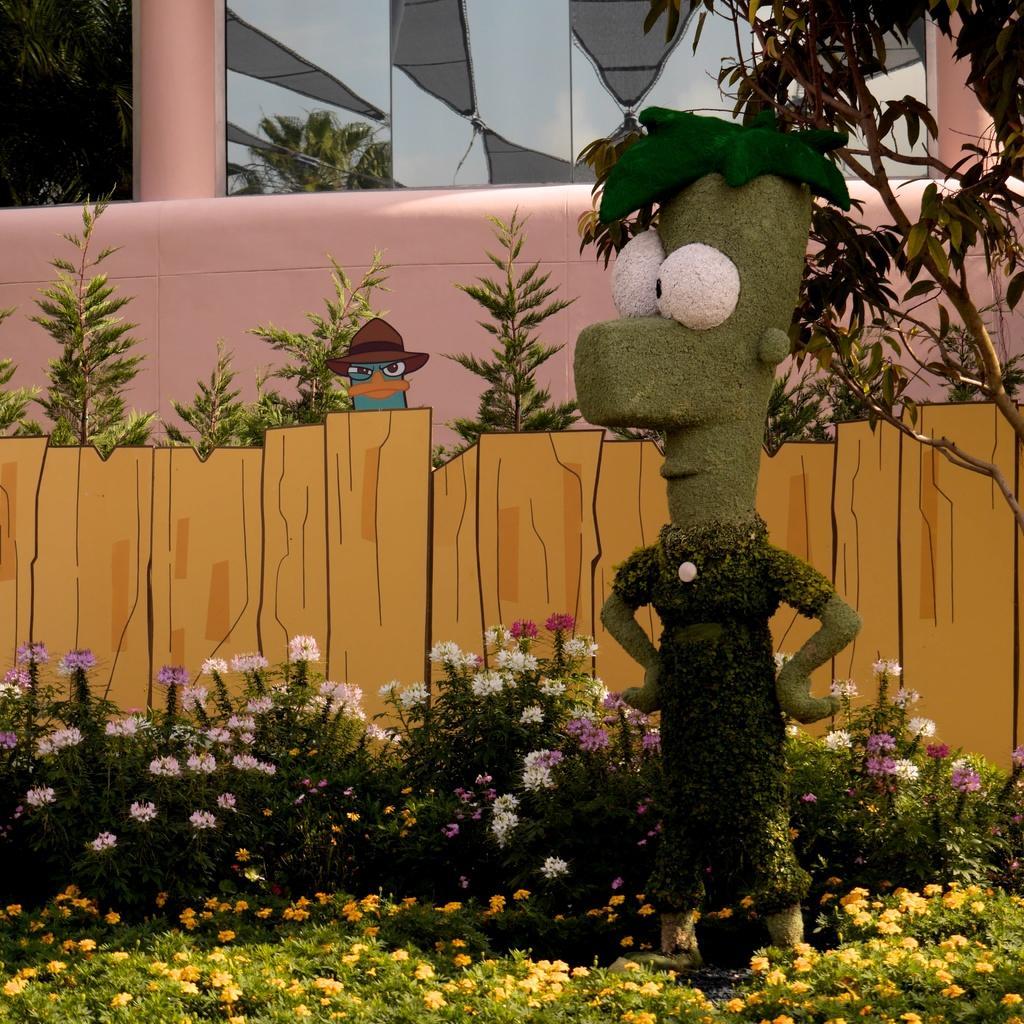Please provide a concise description of this image. In this image, on the right there is a toy. At the bottom there are plants, flowers. At the top there are plants, animated fence, cartoon, building. 